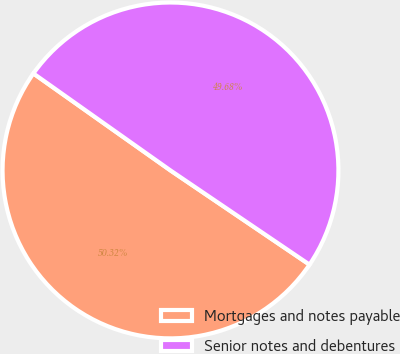Convert chart to OTSL. <chart><loc_0><loc_0><loc_500><loc_500><pie_chart><fcel>Mortgages and notes payable<fcel>Senior notes and debentures<nl><fcel>50.32%<fcel>49.68%<nl></chart> 